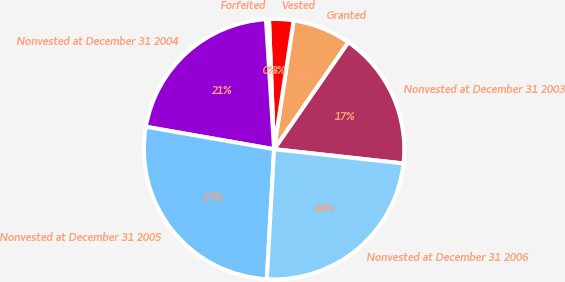<chart> <loc_0><loc_0><loc_500><loc_500><pie_chart><fcel>Nonvested at December 31 2003<fcel>Granted<fcel>Vested<fcel>Forfeited<fcel>Nonvested at December 31 2004<fcel>Nonvested at December 31 2005<fcel>Nonvested at December 31 2006<nl><fcel>17.1%<fcel>7.25%<fcel>3.02%<fcel>0.37%<fcel>21.25%<fcel>26.87%<fcel>24.13%<nl></chart> 